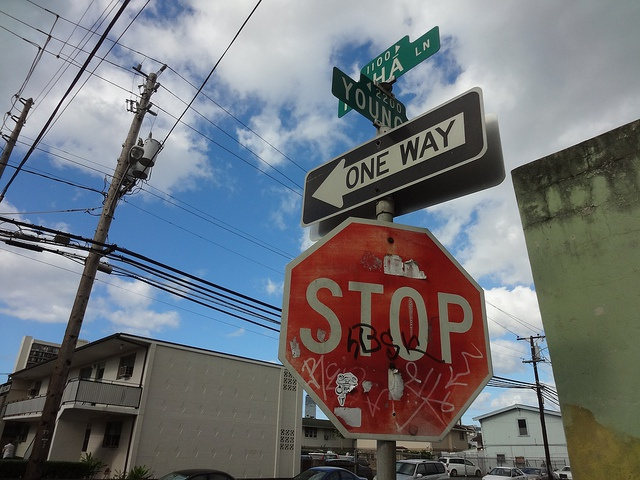Describe the objects in this image and their specific colors. I can see stop sign in gray, maroon, and black tones, car in gray, black, and darkgray tones, car in gray and black tones, car in gray, black, navy, and darkblue tones, and car in gray, darkgray, and black tones in this image. 